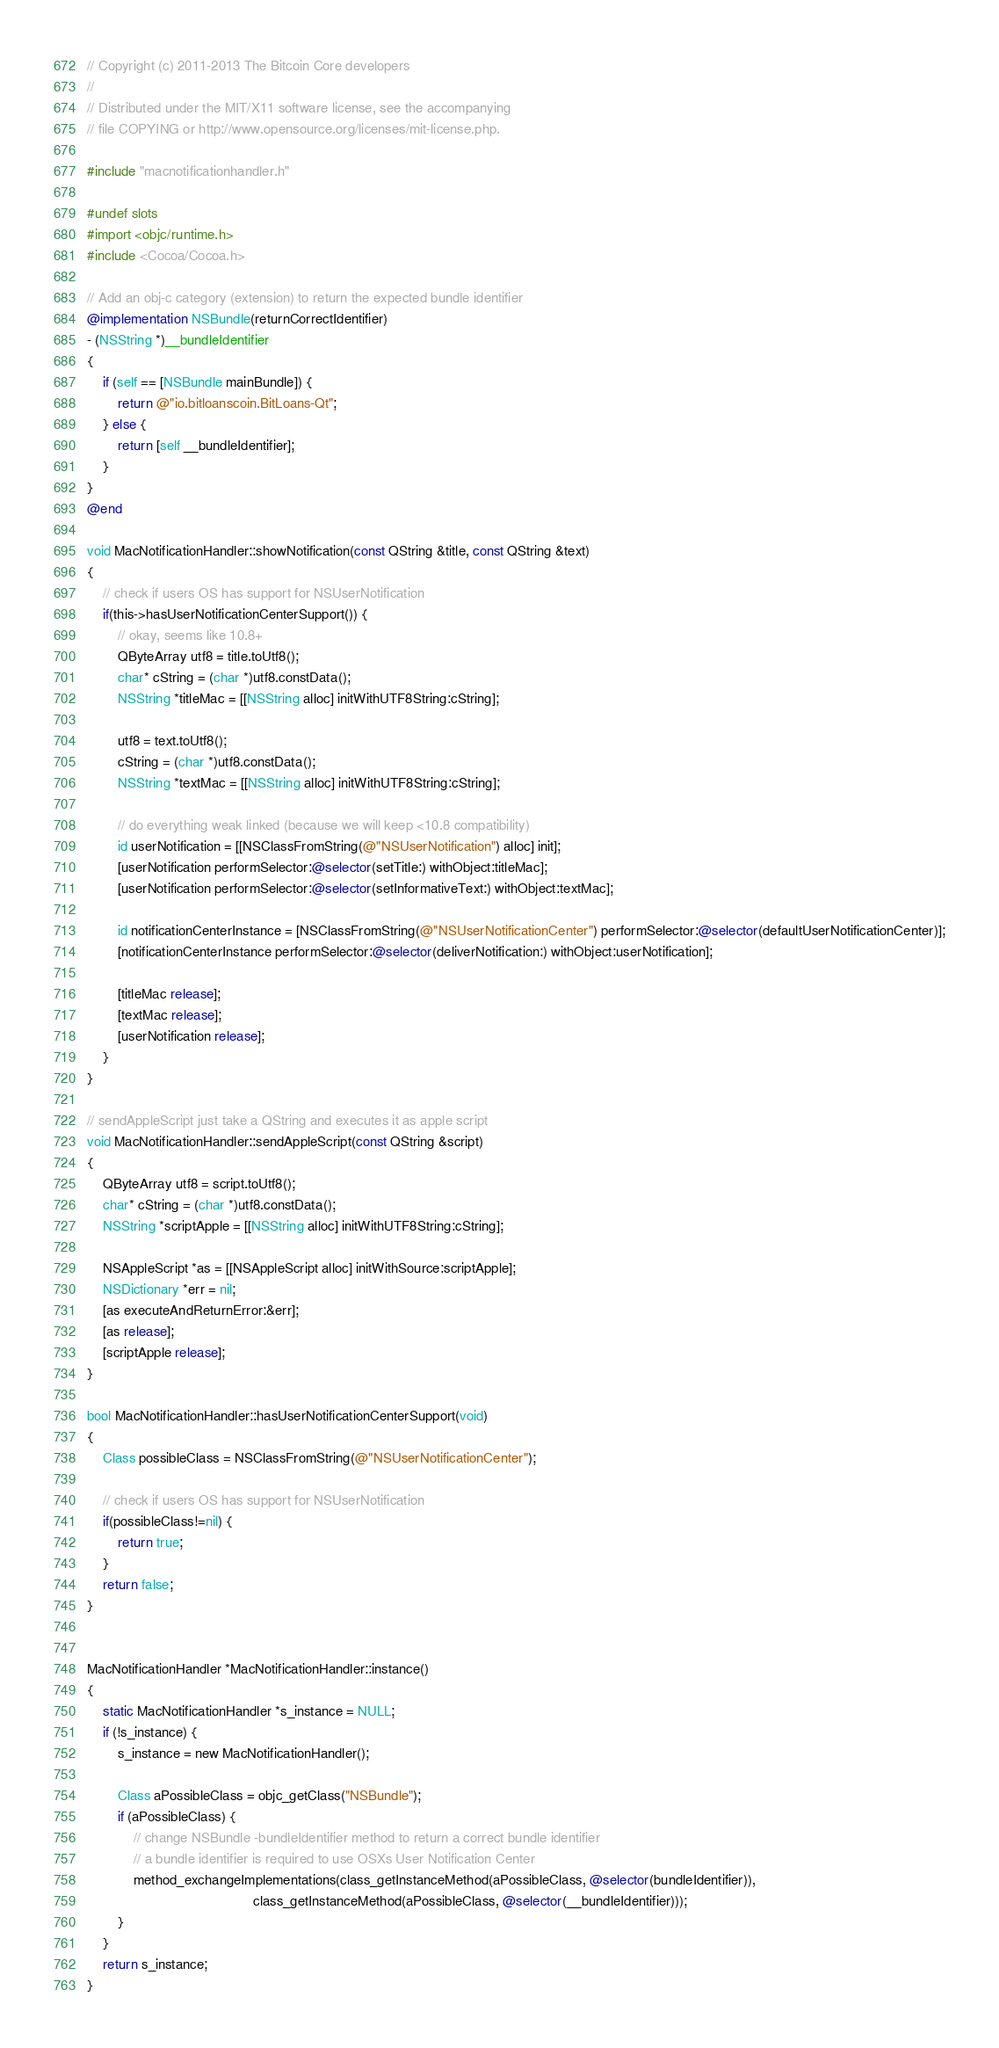Convert code to text. <code><loc_0><loc_0><loc_500><loc_500><_ObjectiveC_>// Copyright (c) 2011-2013 The Bitcoin Core developers
// 
// Distributed under the MIT/X11 software license, see the accompanying
// file COPYING or http://www.opensource.org/licenses/mit-license.php.

#include "macnotificationhandler.h"

#undef slots
#import <objc/runtime.h>
#include <Cocoa/Cocoa.h>

// Add an obj-c category (extension) to return the expected bundle identifier
@implementation NSBundle(returnCorrectIdentifier)
- (NSString *)__bundleIdentifier
{
    if (self == [NSBundle mainBundle]) {
        return @"io.bitloanscoin.BitLoans-Qt";
    } else {
        return [self __bundleIdentifier];
    }
}
@end

void MacNotificationHandler::showNotification(const QString &title, const QString &text)
{
    // check if users OS has support for NSUserNotification
    if(this->hasUserNotificationCenterSupport()) {
        // okay, seems like 10.8+
        QByteArray utf8 = title.toUtf8();
        char* cString = (char *)utf8.constData();
        NSString *titleMac = [[NSString alloc] initWithUTF8String:cString];

        utf8 = text.toUtf8();
        cString = (char *)utf8.constData();
        NSString *textMac = [[NSString alloc] initWithUTF8String:cString];

        // do everything weak linked (because we will keep <10.8 compatibility)
        id userNotification = [[NSClassFromString(@"NSUserNotification") alloc] init];
        [userNotification performSelector:@selector(setTitle:) withObject:titleMac];
        [userNotification performSelector:@selector(setInformativeText:) withObject:textMac];

        id notificationCenterInstance = [NSClassFromString(@"NSUserNotificationCenter") performSelector:@selector(defaultUserNotificationCenter)];
        [notificationCenterInstance performSelector:@selector(deliverNotification:) withObject:userNotification];

        [titleMac release];
        [textMac release];
        [userNotification release];
    }
}

// sendAppleScript just take a QString and executes it as apple script
void MacNotificationHandler::sendAppleScript(const QString &script)
{
    QByteArray utf8 = script.toUtf8();
    char* cString = (char *)utf8.constData();
    NSString *scriptApple = [[NSString alloc] initWithUTF8String:cString];

    NSAppleScript *as = [[NSAppleScript alloc] initWithSource:scriptApple];
    NSDictionary *err = nil;
    [as executeAndReturnError:&err];
    [as release];
    [scriptApple release];
}

bool MacNotificationHandler::hasUserNotificationCenterSupport(void)
{
    Class possibleClass = NSClassFromString(@"NSUserNotificationCenter");

    // check if users OS has support for NSUserNotification
    if(possibleClass!=nil) {
        return true;
    }
    return false;
}


MacNotificationHandler *MacNotificationHandler::instance()
{
    static MacNotificationHandler *s_instance = NULL;
    if (!s_instance) {
        s_instance = new MacNotificationHandler();
        
        Class aPossibleClass = objc_getClass("NSBundle");
        if (aPossibleClass) {
            // change NSBundle -bundleIdentifier method to return a correct bundle identifier
            // a bundle identifier is required to use OSXs User Notification Center
            method_exchangeImplementations(class_getInstanceMethod(aPossibleClass, @selector(bundleIdentifier)),
                                           class_getInstanceMethod(aPossibleClass, @selector(__bundleIdentifier)));
        }
    }
    return s_instance;
}
</code> 